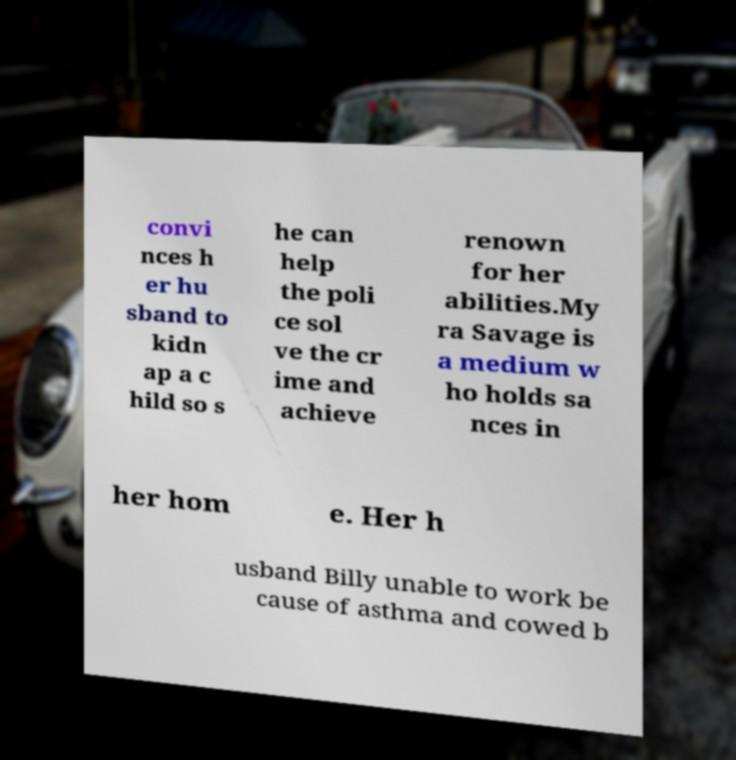Can you read and provide the text displayed in the image?This photo seems to have some interesting text. Can you extract and type it out for me? convi nces h er hu sband to kidn ap a c hild so s he can help the poli ce sol ve the cr ime and achieve renown for her abilities.My ra Savage is a medium w ho holds sa nces in her hom e. Her h usband Billy unable to work be cause of asthma and cowed b 